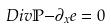Convert formula to latex. <formula><loc_0><loc_0><loc_500><loc_500>D i v \mathbb { P - } \partial _ { x } e = 0</formula> 